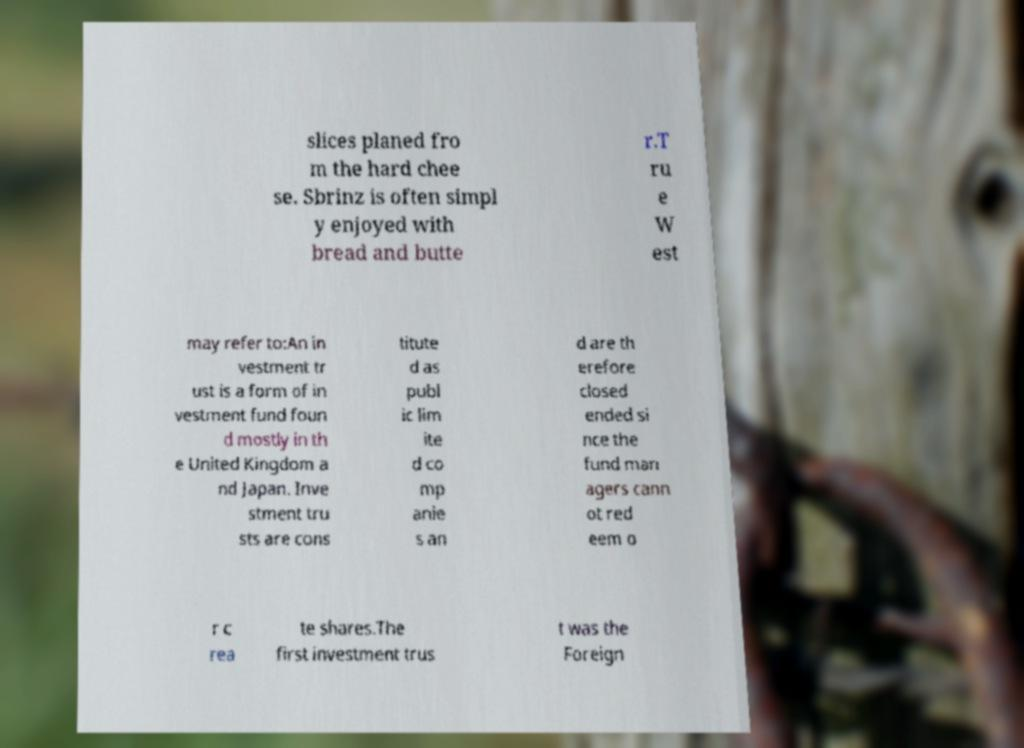Please identify and transcribe the text found in this image. slices planed fro m the hard chee se. Sbrinz is often simpl y enjoyed with bread and butte r.T ru e W est may refer to:An in vestment tr ust is a form of in vestment fund foun d mostly in th e United Kingdom a nd Japan. Inve stment tru sts are cons titute d as publ ic lim ite d co mp anie s an d are th erefore closed ended si nce the fund man agers cann ot red eem o r c rea te shares.The first investment trus t was the Foreign 